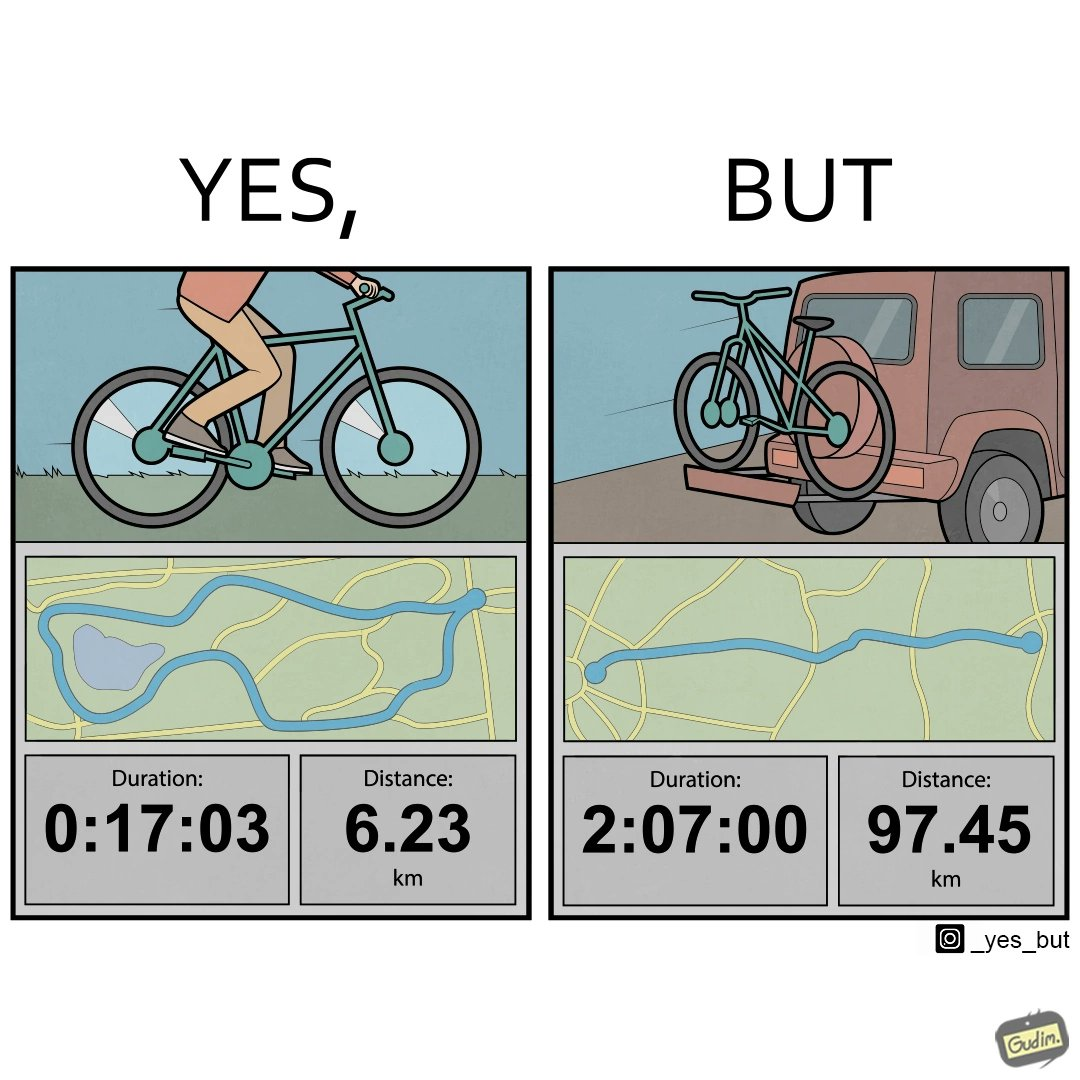Explain why this image is satirical. The image is ironic, because the person has to travel 2 hours just to ride his bicycle for 17 minutes 